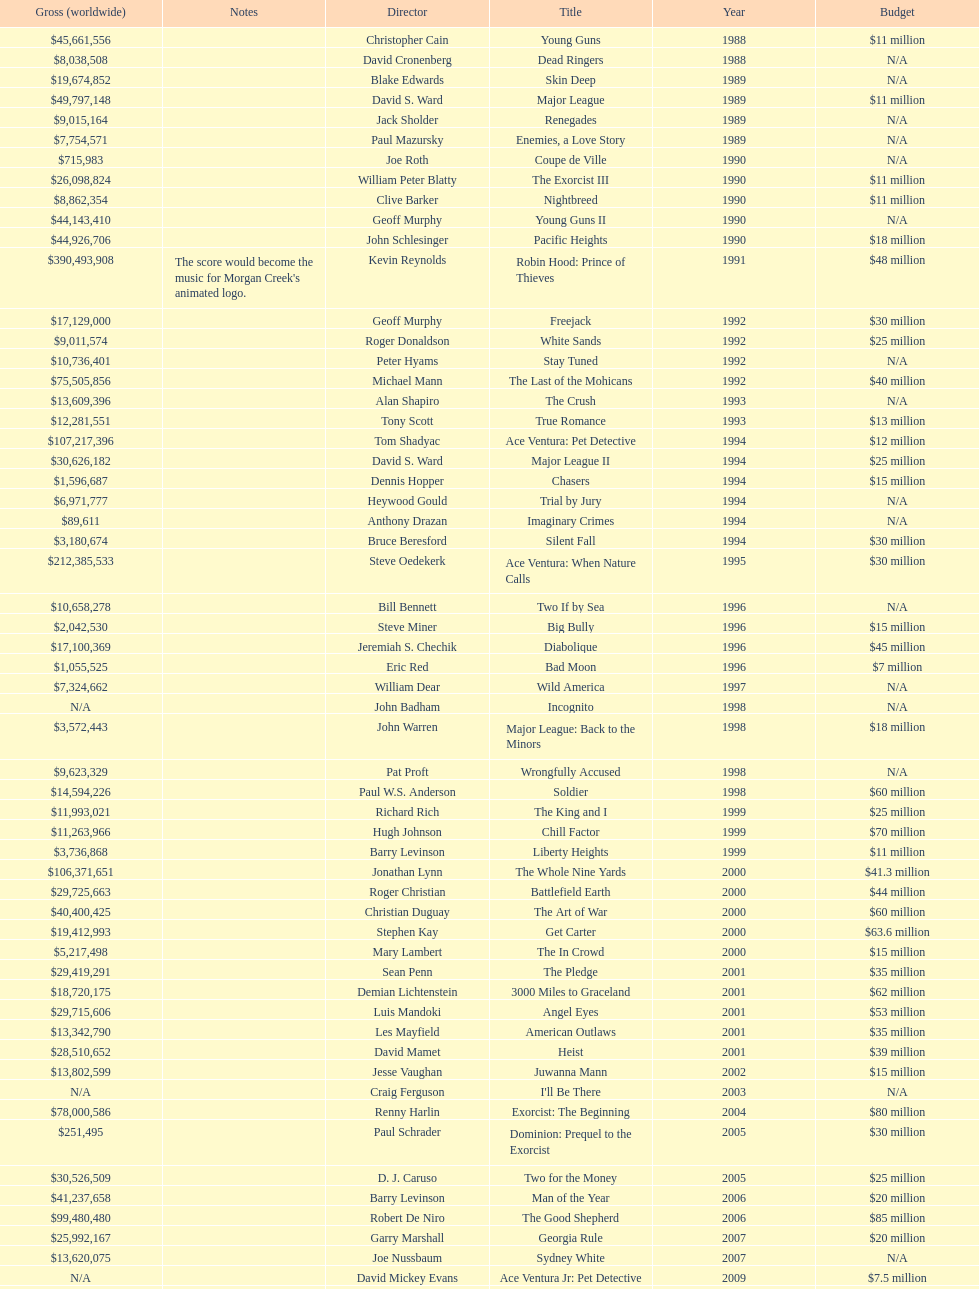I'm looking to parse the entire table for insights. Could you assist me with that? {'header': ['Gross (worldwide)', 'Notes', 'Director', 'Title', 'Year', 'Budget'], 'rows': [['$45,661,556', '', 'Christopher Cain', 'Young Guns', '1988', '$11 million'], ['$8,038,508', '', 'David Cronenberg', 'Dead Ringers', '1988', 'N/A'], ['$19,674,852', '', 'Blake Edwards', 'Skin Deep', '1989', 'N/A'], ['$49,797,148', '', 'David S. Ward', 'Major League', '1989', '$11 million'], ['$9,015,164', '', 'Jack Sholder', 'Renegades', '1989', 'N/A'], ['$7,754,571', '', 'Paul Mazursky', 'Enemies, a Love Story', '1989', 'N/A'], ['$715,983', '', 'Joe Roth', 'Coupe de Ville', '1990', 'N/A'], ['$26,098,824', '', 'William Peter Blatty', 'The Exorcist III', '1990', '$11 million'], ['$8,862,354', '', 'Clive Barker', 'Nightbreed', '1990', '$11 million'], ['$44,143,410', '', 'Geoff Murphy', 'Young Guns II', '1990', 'N/A'], ['$44,926,706', '', 'John Schlesinger', 'Pacific Heights', '1990', '$18 million'], ['$390,493,908', "The score would become the music for Morgan Creek's animated logo.", 'Kevin Reynolds', 'Robin Hood: Prince of Thieves', '1991', '$48 million'], ['$17,129,000', '', 'Geoff Murphy', 'Freejack', '1992', '$30 million'], ['$9,011,574', '', 'Roger Donaldson', 'White Sands', '1992', '$25 million'], ['$10,736,401', '', 'Peter Hyams', 'Stay Tuned', '1992', 'N/A'], ['$75,505,856', '', 'Michael Mann', 'The Last of the Mohicans', '1992', '$40 million'], ['$13,609,396', '', 'Alan Shapiro', 'The Crush', '1993', 'N/A'], ['$12,281,551', '', 'Tony Scott', 'True Romance', '1993', '$13 million'], ['$107,217,396', '', 'Tom Shadyac', 'Ace Ventura: Pet Detective', '1994', '$12 million'], ['$30,626,182', '', 'David S. Ward', 'Major League II', '1994', '$25 million'], ['$1,596,687', '', 'Dennis Hopper', 'Chasers', '1994', '$15 million'], ['$6,971,777', '', 'Heywood Gould', 'Trial by Jury', '1994', 'N/A'], ['$89,611', '', 'Anthony Drazan', 'Imaginary Crimes', '1994', 'N/A'], ['$3,180,674', '', 'Bruce Beresford', 'Silent Fall', '1994', '$30 million'], ['$212,385,533', '', 'Steve Oedekerk', 'Ace Ventura: When Nature Calls', '1995', '$30 million'], ['$10,658,278', '', 'Bill Bennett', 'Two If by Sea', '1996', 'N/A'], ['$2,042,530', '', 'Steve Miner', 'Big Bully', '1996', '$15 million'], ['$17,100,369', '', 'Jeremiah S. Chechik', 'Diabolique', '1996', '$45 million'], ['$1,055,525', '', 'Eric Red', 'Bad Moon', '1996', '$7 million'], ['$7,324,662', '', 'William Dear', 'Wild America', '1997', 'N/A'], ['N/A', '', 'John Badham', 'Incognito', '1998', 'N/A'], ['$3,572,443', '', 'John Warren', 'Major League: Back to the Minors', '1998', '$18 million'], ['$9,623,329', '', 'Pat Proft', 'Wrongfully Accused', '1998', 'N/A'], ['$14,594,226', '', 'Paul W.S. Anderson', 'Soldier', '1998', '$60 million'], ['$11,993,021', '', 'Richard Rich', 'The King and I', '1999', '$25 million'], ['$11,263,966', '', 'Hugh Johnson', 'Chill Factor', '1999', '$70 million'], ['$3,736,868', '', 'Barry Levinson', 'Liberty Heights', '1999', '$11 million'], ['$106,371,651', '', 'Jonathan Lynn', 'The Whole Nine Yards', '2000', '$41.3 million'], ['$29,725,663', '', 'Roger Christian', 'Battlefield Earth', '2000', '$44 million'], ['$40,400,425', '', 'Christian Duguay', 'The Art of War', '2000', '$60 million'], ['$19,412,993', '', 'Stephen Kay', 'Get Carter', '2000', '$63.6 million'], ['$5,217,498', '', 'Mary Lambert', 'The In Crowd', '2000', '$15 million'], ['$29,419,291', '', 'Sean Penn', 'The Pledge', '2001', '$35 million'], ['$18,720,175', '', 'Demian Lichtenstein', '3000 Miles to Graceland', '2001', '$62 million'], ['$29,715,606', '', 'Luis Mandoki', 'Angel Eyes', '2001', '$53 million'], ['$13,342,790', '', 'Les Mayfield', 'American Outlaws', '2001', '$35 million'], ['$28,510,652', '', 'David Mamet', 'Heist', '2001', '$39 million'], ['$13,802,599', '', 'Jesse Vaughan', 'Juwanna Mann', '2002', '$15 million'], ['N/A', '', 'Craig Ferguson', "I'll Be There", '2003', 'N/A'], ['$78,000,586', '', 'Renny Harlin', 'Exorcist: The Beginning', '2004', '$80 million'], ['$251,495', '', 'Paul Schrader', 'Dominion: Prequel to the Exorcist', '2005', '$30 million'], ['$30,526,509', '', 'D. J. Caruso', 'Two for the Money', '2005', '$25 million'], ['$41,237,658', '', 'Barry Levinson', 'Man of the Year', '2006', '$20 million'], ['$99,480,480', '', 'Robert De Niro', 'The Good Shepherd', '2006', '$85 million'], ['$25,992,167', '', 'Garry Marshall', 'Georgia Rule', '2007', '$20 million'], ['$13,620,075', '', 'Joe Nussbaum', 'Sydney White', '2007', 'N/A'], ['N/A', '', 'David Mickey Evans', 'Ace Ventura Jr: Pet Detective', '2009', '$7.5 million'], ['$38,502,340', '', 'Jim Sheridan', 'Dream House', '2011', '$50 million'], ['$27,428,670', '', 'Matthijs van Heijningen Jr.', 'The Thing', '2011', '$38 million'], ['', '', 'Antoine Fuqua', 'Tupac', '2014', '$45 million']]} Which morgan creek film grossed the most money prior to 1994? Robin Hood: Prince of Thieves. 